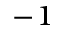Convert formula to latex. <formula><loc_0><loc_0><loc_500><loc_500>^ { - 1 }</formula> 